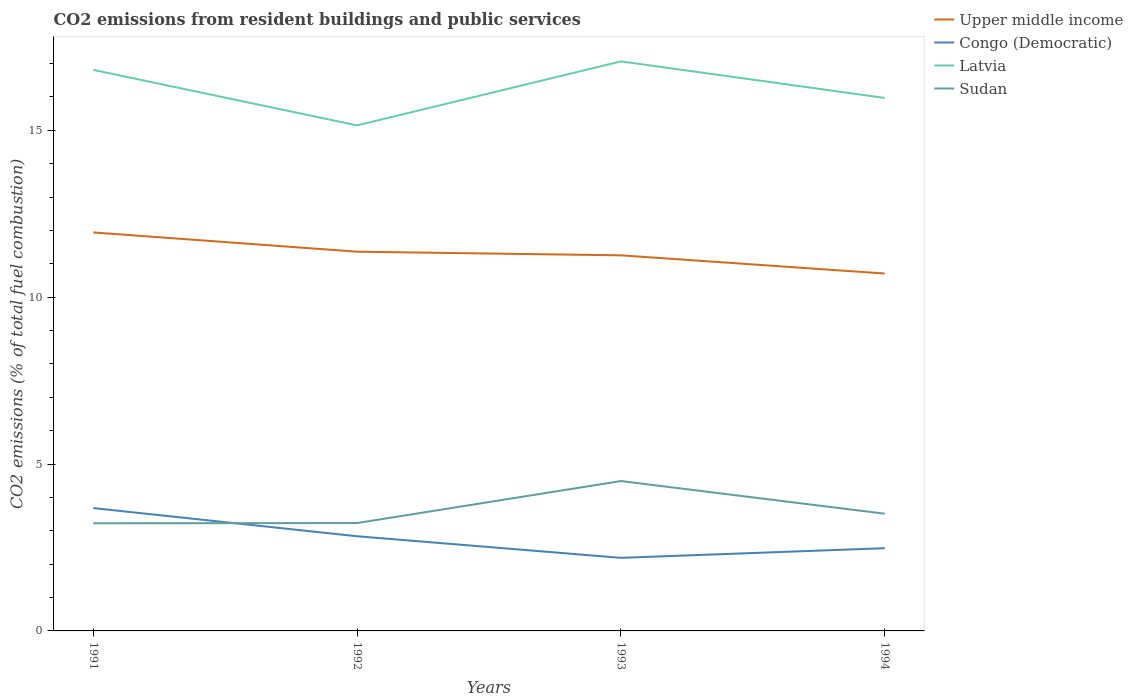Is the number of lines equal to the number of legend labels?
Offer a terse response. Yes. Across all years, what is the maximum total CO2 emitted in Congo (Democratic)?
Offer a terse response. 2.19. What is the total total CO2 emitted in Congo (Democratic) in the graph?
Keep it short and to the point. 0.84. What is the difference between the highest and the second highest total CO2 emitted in Upper middle income?
Offer a very short reply. 1.23. Is the total CO2 emitted in Latvia strictly greater than the total CO2 emitted in Upper middle income over the years?
Offer a very short reply. No. How many lines are there?
Your answer should be very brief. 4. Where does the legend appear in the graph?
Offer a very short reply. Top right. How many legend labels are there?
Provide a short and direct response. 4. How are the legend labels stacked?
Your answer should be compact. Vertical. What is the title of the graph?
Provide a succinct answer. CO2 emissions from resident buildings and public services. What is the label or title of the X-axis?
Give a very brief answer. Years. What is the label or title of the Y-axis?
Your answer should be very brief. CO2 emissions (% of total fuel combustion). What is the CO2 emissions (% of total fuel combustion) in Upper middle income in 1991?
Give a very brief answer. 11.94. What is the CO2 emissions (% of total fuel combustion) of Congo (Democratic) in 1991?
Offer a terse response. 3.68. What is the CO2 emissions (% of total fuel combustion) of Latvia in 1991?
Give a very brief answer. 16.81. What is the CO2 emissions (% of total fuel combustion) of Sudan in 1991?
Make the answer very short. 3.23. What is the CO2 emissions (% of total fuel combustion) in Upper middle income in 1992?
Ensure brevity in your answer.  11.36. What is the CO2 emissions (% of total fuel combustion) in Congo (Democratic) in 1992?
Make the answer very short. 2.84. What is the CO2 emissions (% of total fuel combustion) of Latvia in 1992?
Keep it short and to the point. 15.15. What is the CO2 emissions (% of total fuel combustion) of Sudan in 1992?
Provide a short and direct response. 3.23. What is the CO2 emissions (% of total fuel combustion) in Upper middle income in 1993?
Offer a very short reply. 11.26. What is the CO2 emissions (% of total fuel combustion) in Congo (Democratic) in 1993?
Your answer should be compact. 2.19. What is the CO2 emissions (% of total fuel combustion) of Latvia in 1993?
Your response must be concise. 17.07. What is the CO2 emissions (% of total fuel combustion) of Sudan in 1993?
Keep it short and to the point. 4.49. What is the CO2 emissions (% of total fuel combustion) in Upper middle income in 1994?
Offer a terse response. 10.71. What is the CO2 emissions (% of total fuel combustion) of Congo (Democratic) in 1994?
Your answer should be compact. 2.48. What is the CO2 emissions (% of total fuel combustion) of Latvia in 1994?
Provide a succinct answer. 15.97. What is the CO2 emissions (% of total fuel combustion) in Sudan in 1994?
Offer a terse response. 3.51. Across all years, what is the maximum CO2 emissions (% of total fuel combustion) in Upper middle income?
Make the answer very short. 11.94. Across all years, what is the maximum CO2 emissions (% of total fuel combustion) in Congo (Democratic)?
Offer a terse response. 3.68. Across all years, what is the maximum CO2 emissions (% of total fuel combustion) of Latvia?
Provide a short and direct response. 17.07. Across all years, what is the maximum CO2 emissions (% of total fuel combustion) of Sudan?
Your answer should be very brief. 4.49. Across all years, what is the minimum CO2 emissions (% of total fuel combustion) of Upper middle income?
Provide a short and direct response. 10.71. Across all years, what is the minimum CO2 emissions (% of total fuel combustion) in Congo (Democratic)?
Provide a succinct answer. 2.19. Across all years, what is the minimum CO2 emissions (% of total fuel combustion) of Latvia?
Your answer should be very brief. 15.15. Across all years, what is the minimum CO2 emissions (% of total fuel combustion) of Sudan?
Your response must be concise. 3.23. What is the total CO2 emissions (% of total fuel combustion) of Upper middle income in the graph?
Offer a very short reply. 45.27. What is the total CO2 emissions (% of total fuel combustion) of Congo (Democratic) in the graph?
Provide a short and direct response. 11.19. What is the total CO2 emissions (% of total fuel combustion) of Latvia in the graph?
Offer a terse response. 65. What is the total CO2 emissions (% of total fuel combustion) of Sudan in the graph?
Provide a short and direct response. 14.46. What is the difference between the CO2 emissions (% of total fuel combustion) of Upper middle income in 1991 and that in 1992?
Provide a short and direct response. 0.58. What is the difference between the CO2 emissions (% of total fuel combustion) in Congo (Democratic) in 1991 and that in 1992?
Give a very brief answer. 0.84. What is the difference between the CO2 emissions (% of total fuel combustion) in Latvia in 1991 and that in 1992?
Provide a short and direct response. 1.66. What is the difference between the CO2 emissions (% of total fuel combustion) of Sudan in 1991 and that in 1992?
Ensure brevity in your answer.  -0.01. What is the difference between the CO2 emissions (% of total fuel combustion) in Upper middle income in 1991 and that in 1993?
Provide a succinct answer. 0.69. What is the difference between the CO2 emissions (% of total fuel combustion) of Congo (Democratic) in 1991 and that in 1993?
Your response must be concise. 1.49. What is the difference between the CO2 emissions (% of total fuel combustion) in Latvia in 1991 and that in 1993?
Make the answer very short. -0.25. What is the difference between the CO2 emissions (% of total fuel combustion) in Sudan in 1991 and that in 1993?
Give a very brief answer. -1.27. What is the difference between the CO2 emissions (% of total fuel combustion) in Upper middle income in 1991 and that in 1994?
Keep it short and to the point. 1.23. What is the difference between the CO2 emissions (% of total fuel combustion) of Congo (Democratic) in 1991 and that in 1994?
Ensure brevity in your answer.  1.2. What is the difference between the CO2 emissions (% of total fuel combustion) of Latvia in 1991 and that in 1994?
Offer a very short reply. 0.84. What is the difference between the CO2 emissions (% of total fuel combustion) of Sudan in 1991 and that in 1994?
Offer a very short reply. -0.29. What is the difference between the CO2 emissions (% of total fuel combustion) in Upper middle income in 1992 and that in 1993?
Your answer should be compact. 0.11. What is the difference between the CO2 emissions (% of total fuel combustion) of Congo (Democratic) in 1992 and that in 1993?
Keep it short and to the point. 0.65. What is the difference between the CO2 emissions (% of total fuel combustion) of Latvia in 1992 and that in 1993?
Provide a succinct answer. -1.92. What is the difference between the CO2 emissions (% of total fuel combustion) in Sudan in 1992 and that in 1993?
Provide a short and direct response. -1.26. What is the difference between the CO2 emissions (% of total fuel combustion) of Upper middle income in 1992 and that in 1994?
Ensure brevity in your answer.  0.65. What is the difference between the CO2 emissions (% of total fuel combustion) in Congo (Democratic) in 1992 and that in 1994?
Give a very brief answer. 0.36. What is the difference between the CO2 emissions (% of total fuel combustion) in Latvia in 1992 and that in 1994?
Your answer should be compact. -0.82. What is the difference between the CO2 emissions (% of total fuel combustion) of Sudan in 1992 and that in 1994?
Give a very brief answer. -0.28. What is the difference between the CO2 emissions (% of total fuel combustion) of Upper middle income in 1993 and that in 1994?
Make the answer very short. 0.55. What is the difference between the CO2 emissions (% of total fuel combustion) of Congo (Democratic) in 1993 and that in 1994?
Provide a succinct answer. -0.29. What is the difference between the CO2 emissions (% of total fuel combustion) in Latvia in 1993 and that in 1994?
Give a very brief answer. 1.09. What is the difference between the CO2 emissions (% of total fuel combustion) of Sudan in 1993 and that in 1994?
Offer a very short reply. 0.98. What is the difference between the CO2 emissions (% of total fuel combustion) in Upper middle income in 1991 and the CO2 emissions (% of total fuel combustion) in Congo (Democratic) in 1992?
Make the answer very short. 9.1. What is the difference between the CO2 emissions (% of total fuel combustion) of Upper middle income in 1991 and the CO2 emissions (% of total fuel combustion) of Latvia in 1992?
Provide a short and direct response. -3.21. What is the difference between the CO2 emissions (% of total fuel combustion) in Upper middle income in 1991 and the CO2 emissions (% of total fuel combustion) in Sudan in 1992?
Give a very brief answer. 8.71. What is the difference between the CO2 emissions (% of total fuel combustion) of Congo (Democratic) in 1991 and the CO2 emissions (% of total fuel combustion) of Latvia in 1992?
Provide a succinct answer. -11.47. What is the difference between the CO2 emissions (% of total fuel combustion) of Congo (Democratic) in 1991 and the CO2 emissions (% of total fuel combustion) of Sudan in 1992?
Make the answer very short. 0.45. What is the difference between the CO2 emissions (% of total fuel combustion) of Latvia in 1991 and the CO2 emissions (% of total fuel combustion) of Sudan in 1992?
Give a very brief answer. 13.58. What is the difference between the CO2 emissions (% of total fuel combustion) of Upper middle income in 1991 and the CO2 emissions (% of total fuel combustion) of Congo (Democratic) in 1993?
Offer a very short reply. 9.75. What is the difference between the CO2 emissions (% of total fuel combustion) of Upper middle income in 1991 and the CO2 emissions (% of total fuel combustion) of Latvia in 1993?
Keep it short and to the point. -5.13. What is the difference between the CO2 emissions (% of total fuel combustion) in Upper middle income in 1991 and the CO2 emissions (% of total fuel combustion) in Sudan in 1993?
Your answer should be very brief. 7.45. What is the difference between the CO2 emissions (% of total fuel combustion) of Congo (Democratic) in 1991 and the CO2 emissions (% of total fuel combustion) of Latvia in 1993?
Offer a terse response. -13.39. What is the difference between the CO2 emissions (% of total fuel combustion) in Congo (Democratic) in 1991 and the CO2 emissions (% of total fuel combustion) in Sudan in 1993?
Provide a succinct answer. -0.81. What is the difference between the CO2 emissions (% of total fuel combustion) in Latvia in 1991 and the CO2 emissions (% of total fuel combustion) in Sudan in 1993?
Your answer should be very brief. 12.32. What is the difference between the CO2 emissions (% of total fuel combustion) of Upper middle income in 1991 and the CO2 emissions (% of total fuel combustion) of Congo (Democratic) in 1994?
Give a very brief answer. 9.46. What is the difference between the CO2 emissions (% of total fuel combustion) of Upper middle income in 1991 and the CO2 emissions (% of total fuel combustion) of Latvia in 1994?
Ensure brevity in your answer.  -4.03. What is the difference between the CO2 emissions (% of total fuel combustion) of Upper middle income in 1991 and the CO2 emissions (% of total fuel combustion) of Sudan in 1994?
Make the answer very short. 8.43. What is the difference between the CO2 emissions (% of total fuel combustion) in Congo (Democratic) in 1991 and the CO2 emissions (% of total fuel combustion) in Latvia in 1994?
Your answer should be very brief. -12.29. What is the difference between the CO2 emissions (% of total fuel combustion) in Congo (Democratic) in 1991 and the CO2 emissions (% of total fuel combustion) in Sudan in 1994?
Ensure brevity in your answer.  0.17. What is the difference between the CO2 emissions (% of total fuel combustion) in Latvia in 1991 and the CO2 emissions (% of total fuel combustion) in Sudan in 1994?
Your answer should be compact. 13.3. What is the difference between the CO2 emissions (% of total fuel combustion) in Upper middle income in 1992 and the CO2 emissions (% of total fuel combustion) in Congo (Democratic) in 1993?
Provide a short and direct response. 9.17. What is the difference between the CO2 emissions (% of total fuel combustion) of Upper middle income in 1992 and the CO2 emissions (% of total fuel combustion) of Latvia in 1993?
Your answer should be very brief. -5.7. What is the difference between the CO2 emissions (% of total fuel combustion) in Upper middle income in 1992 and the CO2 emissions (% of total fuel combustion) in Sudan in 1993?
Your answer should be compact. 6.87. What is the difference between the CO2 emissions (% of total fuel combustion) of Congo (Democratic) in 1992 and the CO2 emissions (% of total fuel combustion) of Latvia in 1993?
Provide a succinct answer. -14.23. What is the difference between the CO2 emissions (% of total fuel combustion) in Congo (Democratic) in 1992 and the CO2 emissions (% of total fuel combustion) in Sudan in 1993?
Offer a very short reply. -1.65. What is the difference between the CO2 emissions (% of total fuel combustion) in Latvia in 1992 and the CO2 emissions (% of total fuel combustion) in Sudan in 1993?
Provide a short and direct response. 10.66. What is the difference between the CO2 emissions (% of total fuel combustion) in Upper middle income in 1992 and the CO2 emissions (% of total fuel combustion) in Congo (Democratic) in 1994?
Keep it short and to the point. 8.88. What is the difference between the CO2 emissions (% of total fuel combustion) in Upper middle income in 1992 and the CO2 emissions (% of total fuel combustion) in Latvia in 1994?
Keep it short and to the point. -4.61. What is the difference between the CO2 emissions (% of total fuel combustion) in Upper middle income in 1992 and the CO2 emissions (% of total fuel combustion) in Sudan in 1994?
Your answer should be very brief. 7.85. What is the difference between the CO2 emissions (% of total fuel combustion) of Congo (Democratic) in 1992 and the CO2 emissions (% of total fuel combustion) of Latvia in 1994?
Your response must be concise. -13.14. What is the difference between the CO2 emissions (% of total fuel combustion) in Congo (Democratic) in 1992 and the CO2 emissions (% of total fuel combustion) in Sudan in 1994?
Make the answer very short. -0.68. What is the difference between the CO2 emissions (% of total fuel combustion) in Latvia in 1992 and the CO2 emissions (% of total fuel combustion) in Sudan in 1994?
Give a very brief answer. 11.64. What is the difference between the CO2 emissions (% of total fuel combustion) of Upper middle income in 1993 and the CO2 emissions (% of total fuel combustion) of Congo (Democratic) in 1994?
Provide a succinct answer. 8.78. What is the difference between the CO2 emissions (% of total fuel combustion) of Upper middle income in 1993 and the CO2 emissions (% of total fuel combustion) of Latvia in 1994?
Offer a terse response. -4.72. What is the difference between the CO2 emissions (% of total fuel combustion) of Upper middle income in 1993 and the CO2 emissions (% of total fuel combustion) of Sudan in 1994?
Provide a short and direct response. 7.74. What is the difference between the CO2 emissions (% of total fuel combustion) in Congo (Democratic) in 1993 and the CO2 emissions (% of total fuel combustion) in Latvia in 1994?
Make the answer very short. -13.78. What is the difference between the CO2 emissions (% of total fuel combustion) of Congo (Democratic) in 1993 and the CO2 emissions (% of total fuel combustion) of Sudan in 1994?
Your answer should be compact. -1.32. What is the difference between the CO2 emissions (% of total fuel combustion) of Latvia in 1993 and the CO2 emissions (% of total fuel combustion) of Sudan in 1994?
Your response must be concise. 13.55. What is the average CO2 emissions (% of total fuel combustion) of Upper middle income per year?
Offer a terse response. 11.32. What is the average CO2 emissions (% of total fuel combustion) of Congo (Democratic) per year?
Provide a succinct answer. 2.8. What is the average CO2 emissions (% of total fuel combustion) in Latvia per year?
Your answer should be very brief. 16.25. What is the average CO2 emissions (% of total fuel combustion) in Sudan per year?
Provide a short and direct response. 3.62. In the year 1991, what is the difference between the CO2 emissions (% of total fuel combustion) in Upper middle income and CO2 emissions (% of total fuel combustion) in Congo (Democratic)?
Your response must be concise. 8.26. In the year 1991, what is the difference between the CO2 emissions (% of total fuel combustion) in Upper middle income and CO2 emissions (% of total fuel combustion) in Latvia?
Provide a short and direct response. -4.87. In the year 1991, what is the difference between the CO2 emissions (% of total fuel combustion) of Upper middle income and CO2 emissions (% of total fuel combustion) of Sudan?
Keep it short and to the point. 8.72. In the year 1991, what is the difference between the CO2 emissions (% of total fuel combustion) of Congo (Democratic) and CO2 emissions (% of total fuel combustion) of Latvia?
Offer a terse response. -13.13. In the year 1991, what is the difference between the CO2 emissions (% of total fuel combustion) in Congo (Democratic) and CO2 emissions (% of total fuel combustion) in Sudan?
Make the answer very short. 0.46. In the year 1991, what is the difference between the CO2 emissions (% of total fuel combustion) in Latvia and CO2 emissions (% of total fuel combustion) in Sudan?
Give a very brief answer. 13.59. In the year 1992, what is the difference between the CO2 emissions (% of total fuel combustion) of Upper middle income and CO2 emissions (% of total fuel combustion) of Congo (Democratic)?
Make the answer very short. 8.53. In the year 1992, what is the difference between the CO2 emissions (% of total fuel combustion) in Upper middle income and CO2 emissions (% of total fuel combustion) in Latvia?
Provide a short and direct response. -3.79. In the year 1992, what is the difference between the CO2 emissions (% of total fuel combustion) in Upper middle income and CO2 emissions (% of total fuel combustion) in Sudan?
Give a very brief answer. 8.13. In the year 1992, what is the difference between the CO2 emissions (% of total fuel combustion) of Congo (Democratic) and CO2 emissions (% of total fuel combustion) of Latvia?
Offer a terse response. -12.31. In the year 1992, what is the difference between the CO2 emissions (% of total fuel combustion) in Congo (Democratic) and CO2 emissions (% of total fuel combustion) in Sudan?
Your answer should be very brief. -0.4. In the year 1992, what is the difference between the CO2 emissions (% of total fuel combustion) in Latvia and CO2 emissions (% of total fuel combustion) in Sudan?
Offer a very short reply. 11.92. In the year 1993, what is the difference between the CO2 emissions (% of total fuel combustion) in Upper middle income and CO2 emissions (% of total fuel combustion) in Congo (Democratic)?
Provide a short and direct response. 9.07. In the year 1993, what is the difference between the CO2 emissions (% of total fuel combustion) in Upper middle income and CO2 emissions (% of total fuel combustion) in Latvia?
Offer a terse response. -5.81. In the year 1993, what is the difference between the CO2 emissions (% of total fuel combustion) of Upper middle income and CO2 emissions (% of total fuel combustion) of Sudan?
Offer a very short reply. 6.76. In the year 1993, what is the difference between the CO2 emissions (% of total fuel combustion) of Congo (Democratic) and CO2 emissions (% of total fuel combustion) of Latvia?
Ensure brevity in your answer.  -14.88. In the year 1993, what is the difference between the CO2 emissions (% of total fuel combustion) in Congo (Democratic) and CO2 emissions (% of total fuel combustion) in Sudan?
Make the answer very short. -2.3. In the year 1993, what is the difference between the CO2 emissions (% of total fuel combustion) in Latvia and CO2 emissions (% of total fuel combustion) in Sudan?
Your answer should be compact. 12.58. In the year 1994, what is the difference between the CO2 emissions (% of total fuel combustion) in Upper middle income and CO2 emissions (% of total fuel combustion) in Congo (Democratic)?
Provide a short and direct response. 8.23. In the year 1994, what is the difference between the CO2 emissions (% of total fuel combustion) of Upper middle income and CO2 emissions (% of total fuel combustion) of Latvia?
Offer a terse response. -5.26. In the year 1994, what is the difference between the CO2 emissions (% of total fuel combustion) in Upper middle income and CO2 emissions (% of total fuel combustion) in Sudan?
Your answer should be compact. 7.2. In the year 1994, what is the difference between the CO2 emissions (% of total fuel combustion) of Congo (Democratic) and CO2 emissions (% of total fuel combustion) of Latvia?
Your answer should be compact. -13.49. In the year 1994, what is the difference between the CO2 emissions (% of total fuel combustion) of Congo (Democratic) and CO2 emissions (% of total fuel combustion) of Sudan?
Ensure brevity in your answer.  -1.03. In the year 1994, what is the difference between the CO2 emissions (% of total fuel combustion) in Latvia and CO2 emissions (% of total fuel combustion) in Sudan?
Give a very brief answer. 12.46. What is the ratio of the CO2 emissions (% of total fuel combustion) in Upper middle income in 1991 to that in 1992?
Make the answer very short. 1.05. What is the ratio of the CO2 emissions (% of total fuel combustion) of Congo (Democratic) in 1991 to that in 1992?
Ensure brevity in your answer.  1.3. What is the ratio of the CO2 emissions (% of total fuel combustion) of Latvia in 1991 to that in 1992?
Keep it short and to the point. 1.11. What is the ratio of the CO2 emissions (% of total fuel combustion) of Sudan in 1991 to that in 1992?
Offer a terse response. 1. What is the ratio of the CO2 emissions (% of total fuel combustion) in Upper middle income in 1991 to that in 1993?
Provide a short and direct response. 1.06. What is the ratio of the CO2 emissions (% of total fuel combustion) of Congo (Democratic) in 1991 to that in 1993?
Your answer should be compact. 1.68. What is the ratio of the CO2 emissions (% of total fuel combustion) in Latvia in 1991 to that in 1993?
Your answer should be very brief. 0.99. What is the ratio of the CO2 emissions (% of total fuel combustion) of Sudan in 1991 to that in 1993?
Give a very brief answer. 0.72. What is the ratio of the CO2 emissions (% of total fuel combustion) in Upper middle income in 1991 to that in 1994?
Make the answer very short. 1.11. What is the ratio of the CO2 emissions (% of total fuel combustion) of Congo (Democratic) in 1991 to that in 1994?
Your response must be concise. 1.48. What is the ratio of the CO2 emissions (% of total fuel combustion) of Latvia in 1991 to that in 1994?
Make the answer very short. 1.05. What is the ratio of the CO2 emissions (% of total fuel combustion) in Sudan in 1991 to that in 1994?
Make the answer very short. 0.92. What is the ratio of the CO2 emissions (% of total fuel combustion) of Upper middle income in 1992 to that in 1993?
Provide a short and direct response. 1.01. What is the ratio of the CO2 emissions (% of total fuel combustion) of Congo (Democratic) in 1992 to that in 1993?
Make the answer very short. 1.3. What is the ratio of the CO2 emissions (% of total fuel combustion) in Latvia in 1992 to that in 1993?
Give a very brief answer. 0.89. What is the ratio of the CO2 emissions (% of total fuel combustion) in Sudan in 1992 to that in 1993?
Offer a very short reply. 0.72. What is the ratio of the CO2 emissions (% of total fuel combustion) in Upper middle income in 1992 to that in 1994?
Make the answer very short. 1.06. What is the ratio of the CO2 emissions (% of total fuel combustion) in Congo (Democratic) in 1992 to that in 1994?
Offer a terse response. 1.14. What is the ratio of the CO2 emissions (% of total fuel combustion) in Latvia in 1992 to that in 1994?
Make the answer very short. 0.95. What is the ratio of the CO2 emissions (% of total fuel combustion) in Sudan in 1992 to that in 1994?
Provide a short and direct response. 0.92. What is the ratio of the CO2 emissions (% of total fuel combustion) in Upper middle income in 1993 to that in 1994?
Your answer should be compact. 1.05. What is the ratio of the CO2 emissions (% of total fuel combustion) of Congo (Democratic) in 1993 to that in 1994?
Offer a very short reply. 0.88. What is the ratio of the CO2 emissions (% of total fuel combustion) of Latvia in 1993 to that in 1994?
Your answer should be compact. 1.07. What is the ratio of the CO2 emissions (% of total fuel combustion) of Sudan in 1993 to that in 1994?
Provide a succinct answer. 1.28. What is the difference between the highest and the second highest CO2 emissions (% of total fuel combustion) of Upper middle income?
Provide a succinct answer. 0.58. What is the difference between the highest and the second highest CO2 emissions (% of total fuel combustion) in Congo (Democratic)?
Give a very brief answer. 0.84. What is the difference between the highest and the second highest CO2 emissions (% of total fuel combustion) in Latvia?
Make the answer very short. 0.25. What is the difference between the highest and the second highest CO2 emissions (% of total fuel combustion) in Sudan?
Provide a succinct answer. 0.98. What is the difference between the highest and the lowest CO2 emissions (% of total fuel combustion) in Upper middle income?
Offer a very short reply. 1.23. What is the difference between the highest and the lowest CO2 emissions (% of total fuel combustion) of Congo (Democratic)?
Your answer should be very brief. 1.49. What is the difference between the highest and the lowest CO2 emissions (% of total fuel combustion) in Latvia?
Your answer should be compact. 1.92. What is the difference between the highest and the lowest CO2 emissions (% of total fuel combustion) of Sudan?
Your answer should be compact. 1.27. 